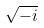<formula> <loc_0><loc_0><loc_500><loc_500>\sqrt { - i }</formula> 